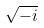<formula> <loc_0><loc_0><loc_500><loc_500>\sqrt { - i }</formula> 